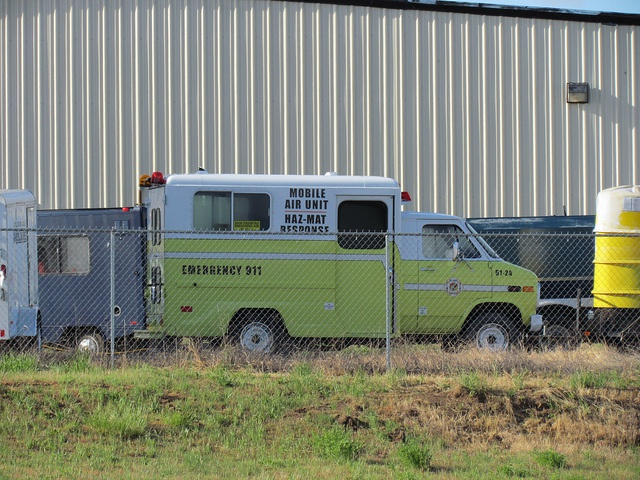Describe the objects in this image and their specific colors. I can see a truck in gray, olive, and black tones in this image. 